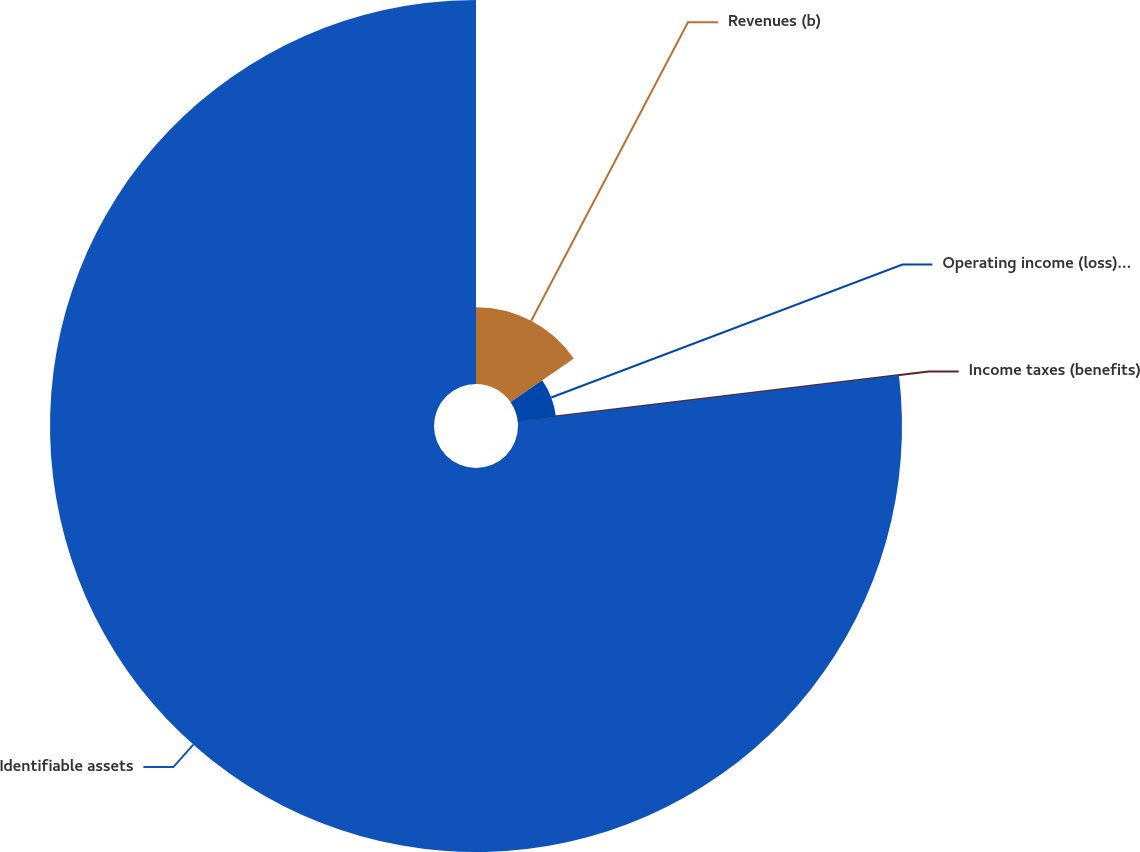Convert chart. <chart><loc_0><loc_0><loc_500><loc_500><pie_chart><fcel>Revenues (b)<fcel>Operating income (loss) before<fcel>Income taxes (benefits)<fcel>Identifiable assets<nl><fcel>15.39%<fcel>7.7%<fcel>0.01%<fcel>76.91%<nl></chart> 